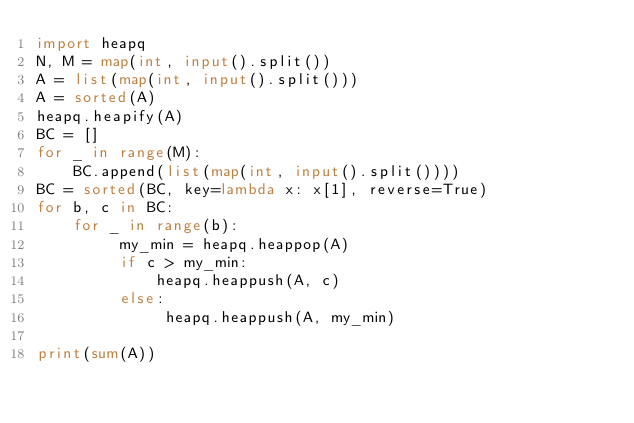Convert code to text. <code><loc_0><loc_0><loc_500><loc_500><_Python_>import heapq
N, M = map(int, input().split())
A = list(map(int, input().split()))
A = sorted(A)
heapq.heapify(A)
BC = []
for _ in range(M):
    BC.append(list(map(int, input().split())))
BC = sorted(BC, key=lambda x: x[1], reverse=True)
for b, c in BC:
    for _ in range(b):
         my_min = heapq.heappop(A)
         if c > my_min:
             heapq.heappush(A, c)
         else:
              heapq.heappush(A, my_min)

print(sum(A))</code> 